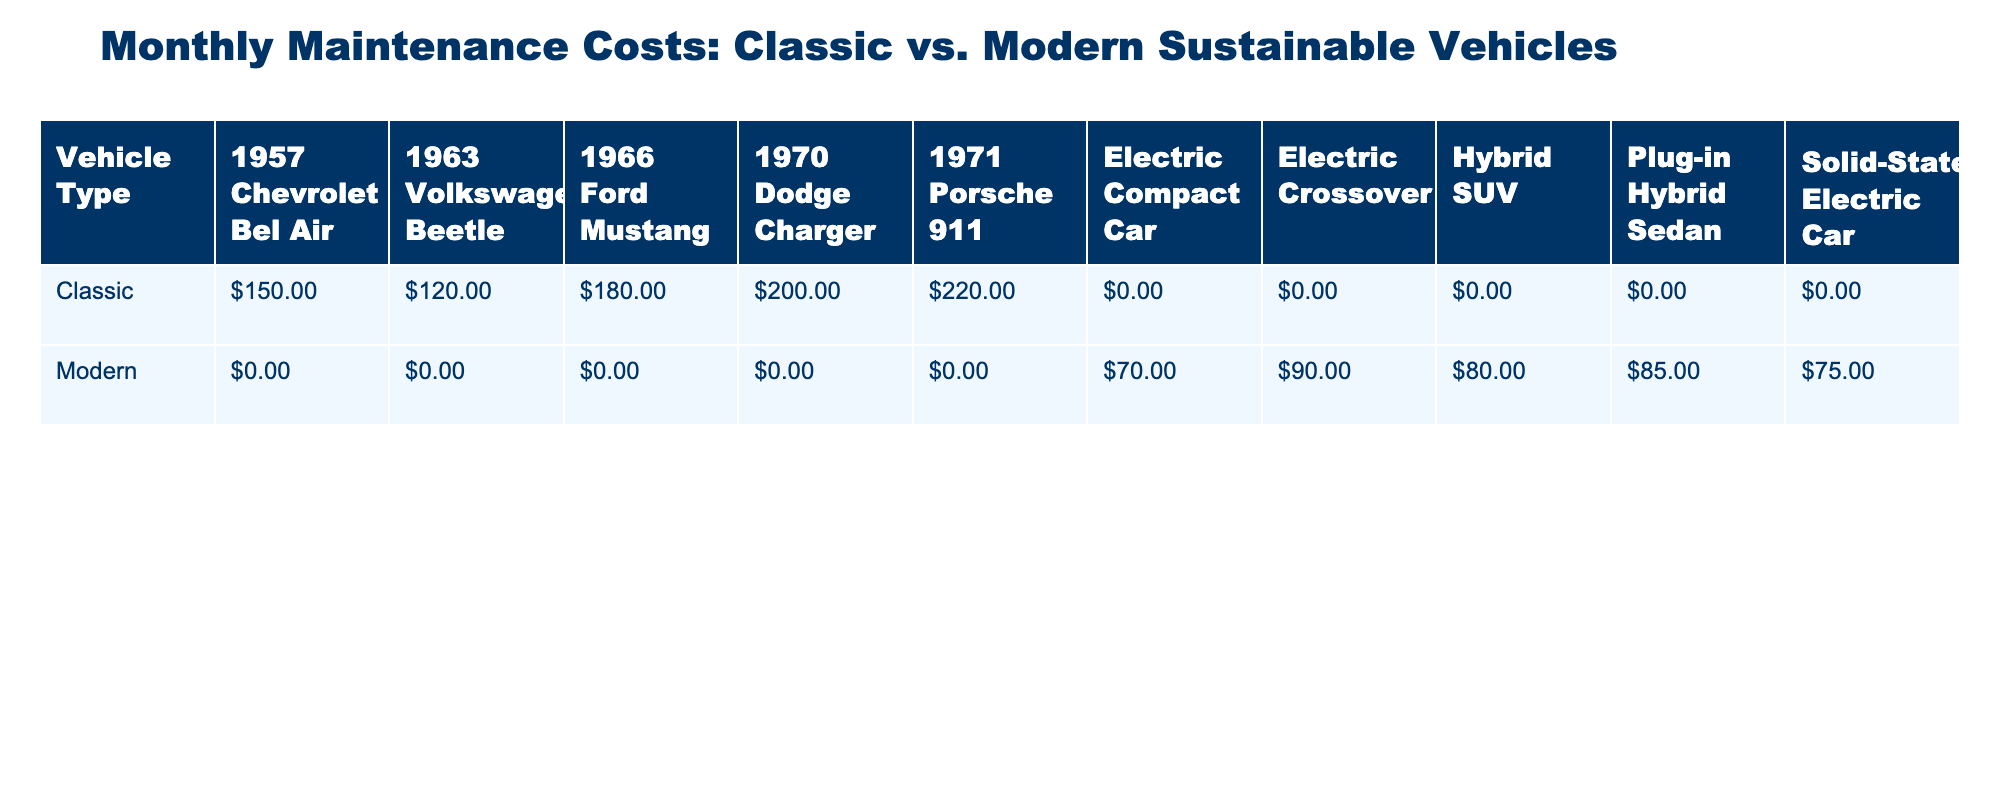What is the highest monthly maintenance cost among classic vehicles? The classic vehicles listed in the table have the following monthly maintenance costs: 150 for the Chevrolet Bel Air, 180 for the Ford Mustang, 200 for the Dodge Charger, 120 for the Volkswagen Beetle, and 220 for the Porsche 911. The highest cost is 220 for the Porsche 911.
Answer: 220 What is the monthly maintenance cost of the Electric Compact Car? The table shows that the monthly maintenance cost for the Electric Compact Car under modern vehicles is 70.
Answer: 70 Is the monthly maintenance cost of the Plug-in Hybrid Sedan higher than that of the 1970 Dodge Charger? The monthly maintenance cost of the Plug-in Hybrid Sedan is 85, while the 1970 Dodge Charger's cost is 200. Since 85 is not higher than 200, the statement is false.
Answer: No What is the average monthly maintenance cost of modern vehicles? The costs for modern vehicles are 75 for the Solid-State Electric Car, 80 for the Hybrid SUV, 70 for the Electric Compact Car, 85 for the Plug-in Hybrid Sedan, and 90 for the Electric Crossover. To find the average, we sum these values: (75 + 80 + 70 + 85 + 90) = 400. Since there are 5 vehicles, we divide: 400 / 5 = 80.
Answer: 80 Which vehicle type has the highest overall monthly maintenance cost when considering all associated models? For classic vehicles, the costs are 150, 180, 200, 120, and 220, giving a total of 1070 for five models. For modern vehicles, the costs are 75, 80, 70, 85, and 90, totaling 400 for five models. Since 1070 is higher than 400, classic vehicles have the higher overall maintenance cost.
Answer: Classic What is the difference in maintenance costs between the 1963 Volkswagen Beetle and the Hybrid SUV? The 1963 Volkswagen Beetle's maintenance cost is 120, while the Hybrid SUV's cost is 80. To find the difference, we subtract: 120 - 80 = 40.
Answer: 40 Are all classic vehicles more expensive to maintain than modern vehicles? The lowest maintenance cost for classic vehicles is 120 for the Volkswagen Beetle which is higher than the highest cost for modern vehicles which is 90 for the Electric Crossover. Thus, the statement is false.
Answer: No What is the total monthly maintenance cost for all classic vehicles combined? The monthly maintenance costs for classic vehicles are 150, 180, 200, 120, and 220. We sum these values: 150 + 180 + 200 + 120 + 220 = 1070.
Answer: 1070 